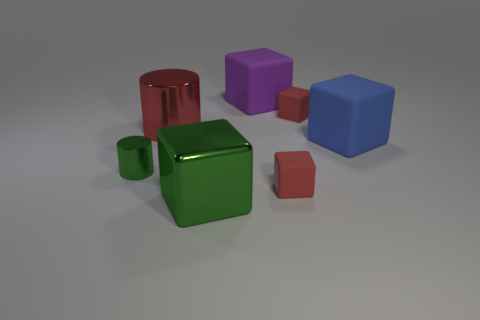Subtract all large blue matte cubes. How many cubes are left? 4 Subtract all green cubes. How many cubes are left? 4 Subtract 1 blocks. How many blocks are left? 4 Add 1 big red metallic things. How many objects exist? 8 Subtract all cyan blocks. Subtract all red cylinders. How many blocks are left? 5 Subtract all cubes. How many objects are left? 2 Add 5 green metallic things. How many green metallic things are left? 7 Add 4 big gray matte things. How many big gray matte things exist? 4 Subtract 0 red balls. How many objects are left? 7 Subtract all red objects. Subtract all small blue metallic cubes. How many objects are left? 4 